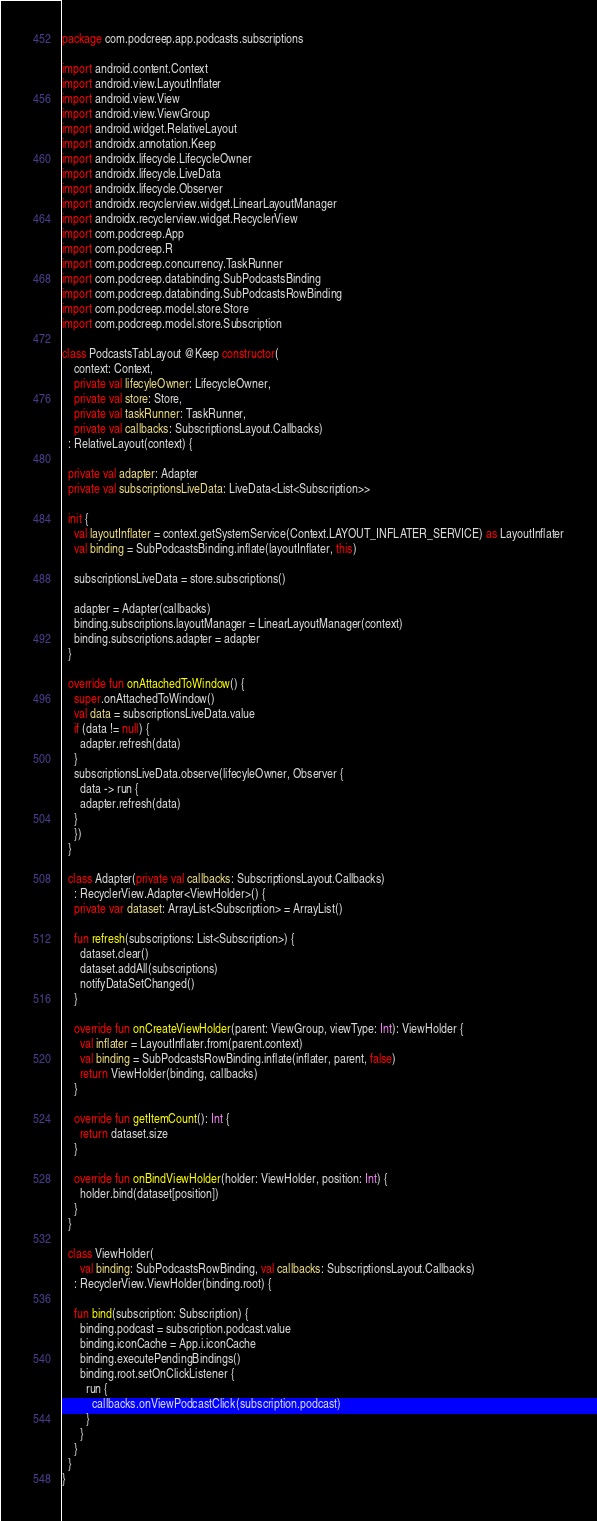Convert code to text. <code><loc_0><loc_0><loc_500><loc_500><_Kotlin_>package com.podcreep.app.podcasts.subscriptions

import android.content.Context
import android.view.LayoutInflater
import android.view.View
import android.view.ViewGroup
import android.widget.RelativeLayout
import androidx.annotation.Keep
import androidx.lifecycle.LifecycleOwner
import androidx.lifecycle.LiveData
import androidx.lifecycle.Observer
import androidx.recyclerview.widget.LinearLayoutManager
import androidx.recyclerview.widget.RecyclerView
import com.podcreep.App
import com.podcreep.R
import com.podcreep.concurrency.TaskRunner
import com.podcreep.databinding.SubPodcastsBinding
import com.podcreep.databinding.SubPodcastsRowBinding
import com.podcreep.model.store.Store
import com.podcreep.model.store.Subscription

class PodcastsTabLayout @Keep constructor(
    context: Context,
    private val lifecyleOwner: LifecycleOwner,
    private val store: Store,
    private val taskRunner: TaskRunner,
    private val callbacks: SubscriptionsLayout.Callbacks)
  : RelativeLayout(context) {

  private val adapter: Adapter
  private val subscriptionsLiveData: LiveData<List<Subscription>>

  init {
    val layoutInflater = context.getSystemService(Context.LAYOUT_INFLATER_SERVICE) as LayoutInflater
    val binding = SubPodcastsBinding.inflate(layoutInflater, this)

    subscriptionsLiveData = store.subscriptions()

    adapter = Adapter(callbacks)
    binding.subscriptions.layoutManager = LinearLayoutManager(context)
    binding.subscriptions.adapter = adapter
  }

  override fun onAttachedToWindow() {
    super.onAttachedToWindow()
    val data = subscriptionsLiveData.value
    if (data != null) {
      adapter.refresh(data)
    }
    subscriptionsLiveData.observe(lifecyleOwner, Observer {
      data -> run {
      adapter.refresh(data)
    }
    })
  }

  class Adapter(private val callbacks: SubscriptionsLayout.Callbacks)
    : RecyclerView.Adapter<ViewHolder>() {
    private var dataset: ArrayList<Subscription> = ArrayList()

    fun refresh(subscriptions: List<Subscription>) {
      dataset.clear()
      dataset.addAll(subscriptions)
      notifyDataSetChanged()
    }

    override fun onCreateViewHolder(parent: ViewGroup, viewType: Int): ViewHolder {
      val inflater = LayoutInflater.from(parent.context)
      val binding = SubPodcastsRowBinding.inflate(inflater, parent, false)
      return ViewHolder(binding, callbacks)
    }

    override fun getItemCount(): Int {
      return dataset.size
    }

    override fun onBindViewHolder(holder: ViewHolder, position: Int) {
      holder.bind(dataset[position])
    }
  }

  class ViewHolder(
      val binding: SubPodcastsRowBinding, val callbacks: SubscriptionsLayout.Callbacks)
    : RecyclerView.ViewHolder(binding.root) {

    fun bind(subscription: Subscription) {
      binding.podcast = subscription.podcast.value
      binding.iconCache = App.i.iconCache
      binding.executePendingBindings()
      binding.root.setOnClickListener {
        run {
          callbacks.onViewPodcastClick(subscription.podcast)
        }
      }
    }
  }
}
</code> 